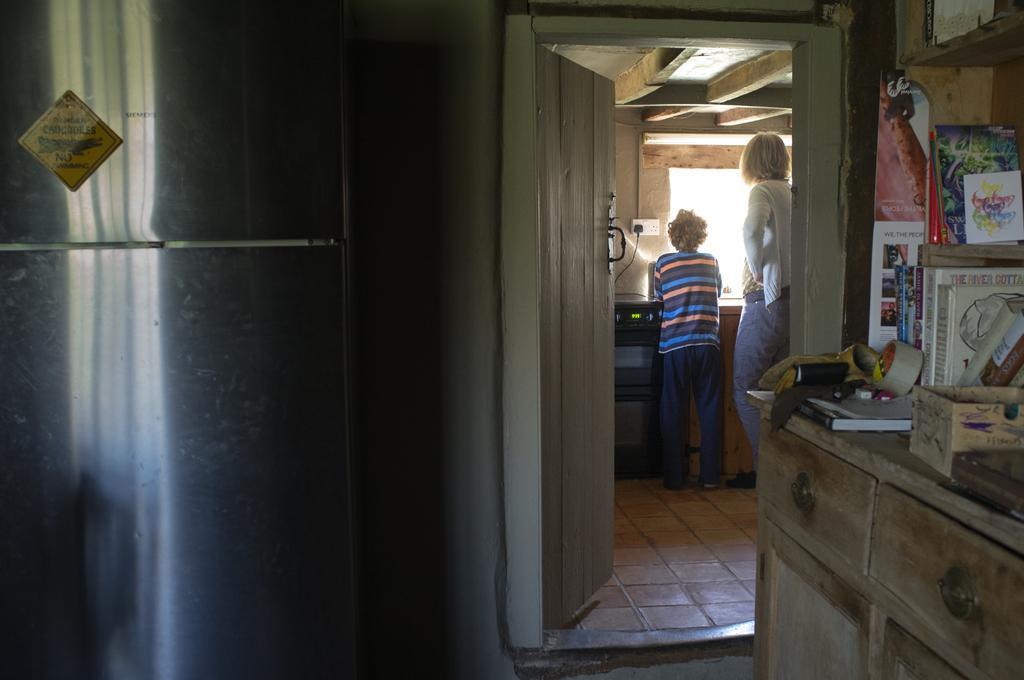Could you give a brief overview of what you see in this image? In the right side there is a cupboard. On the cupboard there are books, box, insulation tape, and some other items. In the back there is a door, and two persons are standing. On the wall there is a socket and a plug. In the left there is a notice on the wall. 